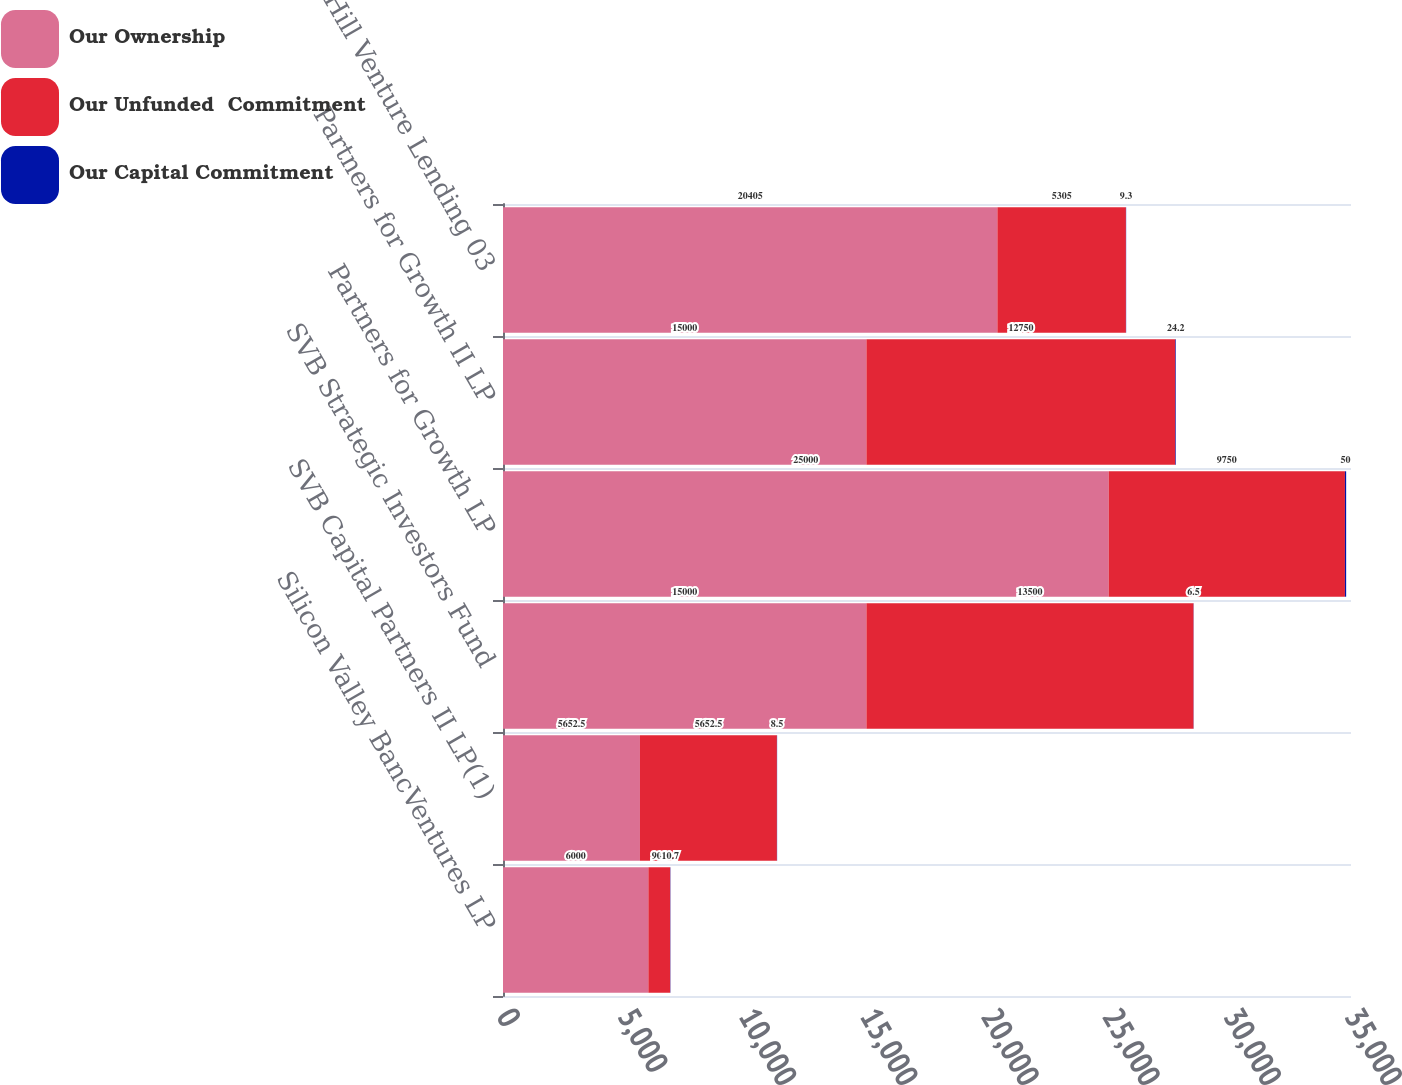<chart> <loc_0><loc_0><loc_500><loc_500><stacked_bar_chart><ecel><fcel>Silicon Valley BancVentures LP<fcel>SVB Capital Partners II LP(1)<fcel>SVB Strategic Investors Fund<fcel>Partners for Growth LP<fcel>Partners for Growth II LP<fcel>Gold Hill Venture Lending 03<nl><fcel>Our Ownership<fcel>6000<fcel>5652.5<fcel>15000<fcel>25000<fcel>15000<fcel>20405<nl><fcel>Our Unfunded  Commitment<fcel>900<fcel>5652.5<fcel>13500<fcel>9750<fcel>12750<fcel>5305<nl><fcel>Our Capital Commitment<fcel>10.7<fcel>8.5<fcel>6.5<fcel>50<fcel>24.2<fcel>9.3<nl></chart> 